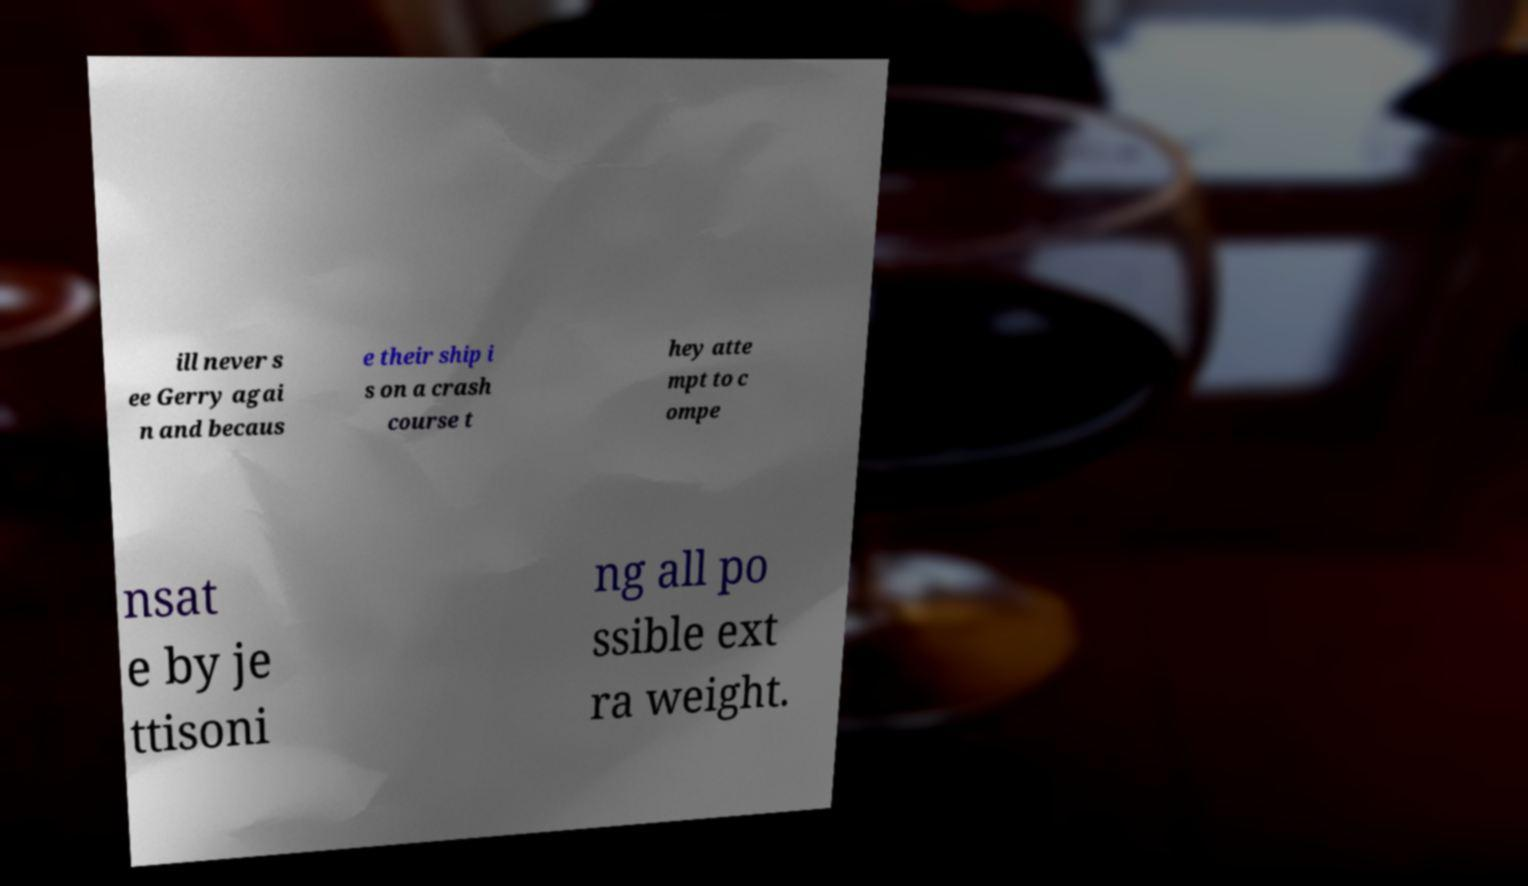Please identify and transcribe the text found in this image. ill never s ee Gerry agai n and becaus e their ship i s on a crash course t hey atte mpt to c ompe nsat e by je ttisoni ng all po ssible ext ra weight. 